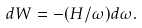<formula> <loc_0><loc_0><loc_500><loc_500>d W = - ( H / \omega ) d \omega .</formula> 